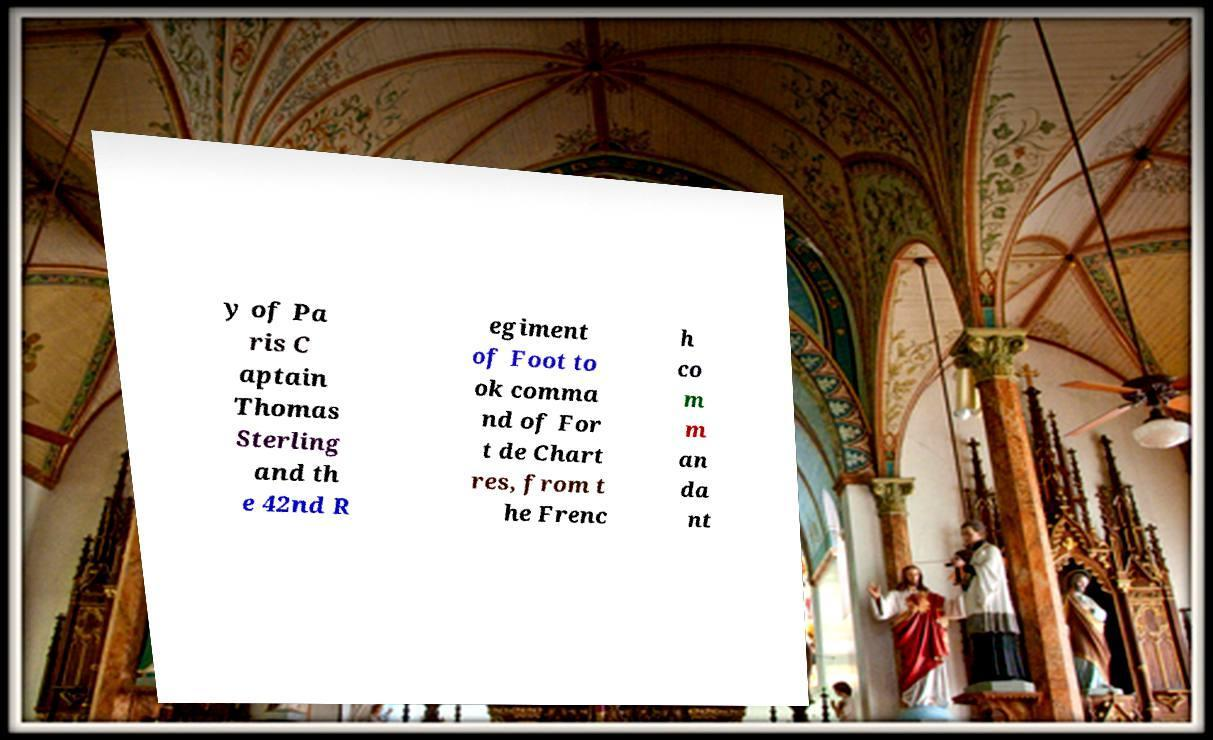There's text embedded in this image that I need extracted. Can you transcribe it verbatim? y of Pa ris C aptain Thomas Sterling and th e 42nd R egiment of Foot to ok comma nd of For t de Chart res, from t he Frenc h co m m an da nt 